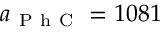Convert formula to latex. <formula><loc_0><loc_0><loc_500><loc_500>a _ { P h C } = 1 0 8 1</formula> 